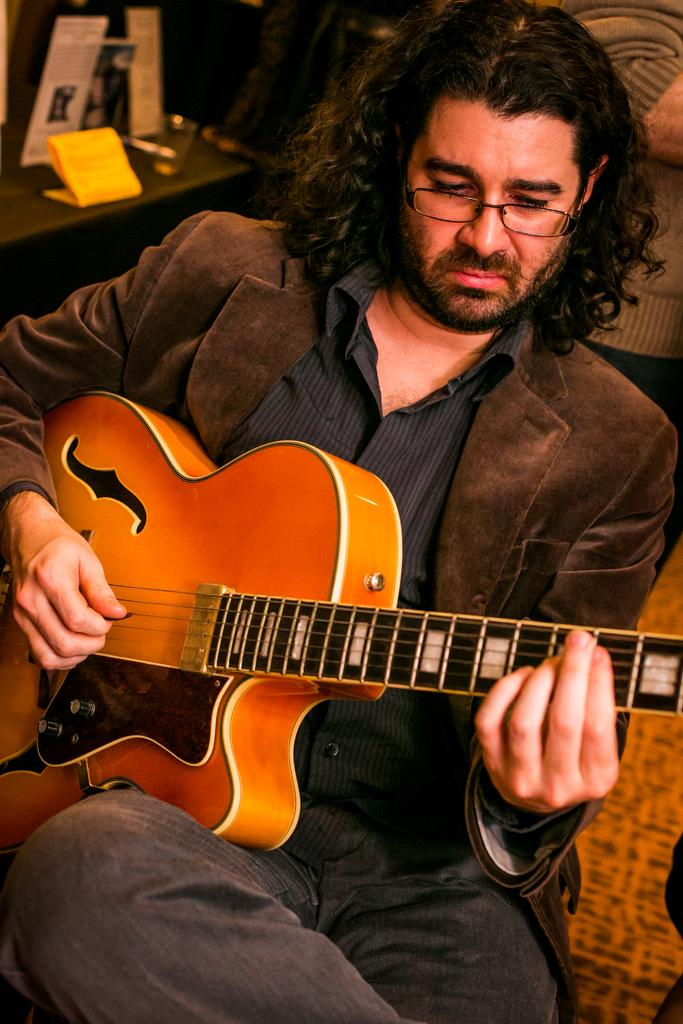What is the main subject of the image? There is a man in the image. What is the man holding in the image? The man is holding a guitar. What type of trick is the man performing with the guitar in the image? There is no trick being performed in the image; the man is simply holding a guitar. 